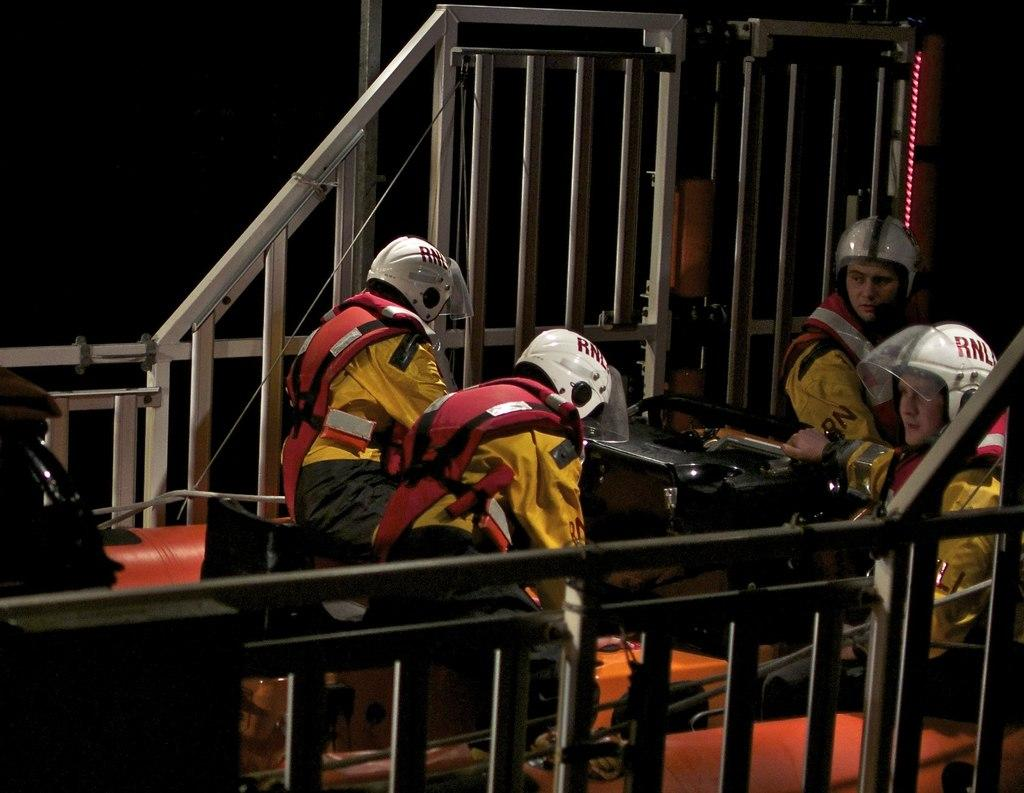How many people are in the image? There are four persons in the image. What are the persons wearing on their heads? The persons are wearing helmets. What can be observed about the background of the image? The background of the image is dark. Are the persons in the image sleeping or resting? There is no indication in the image that the persons are sleeping or resting; they are wearing helmets and the context is not clear. 